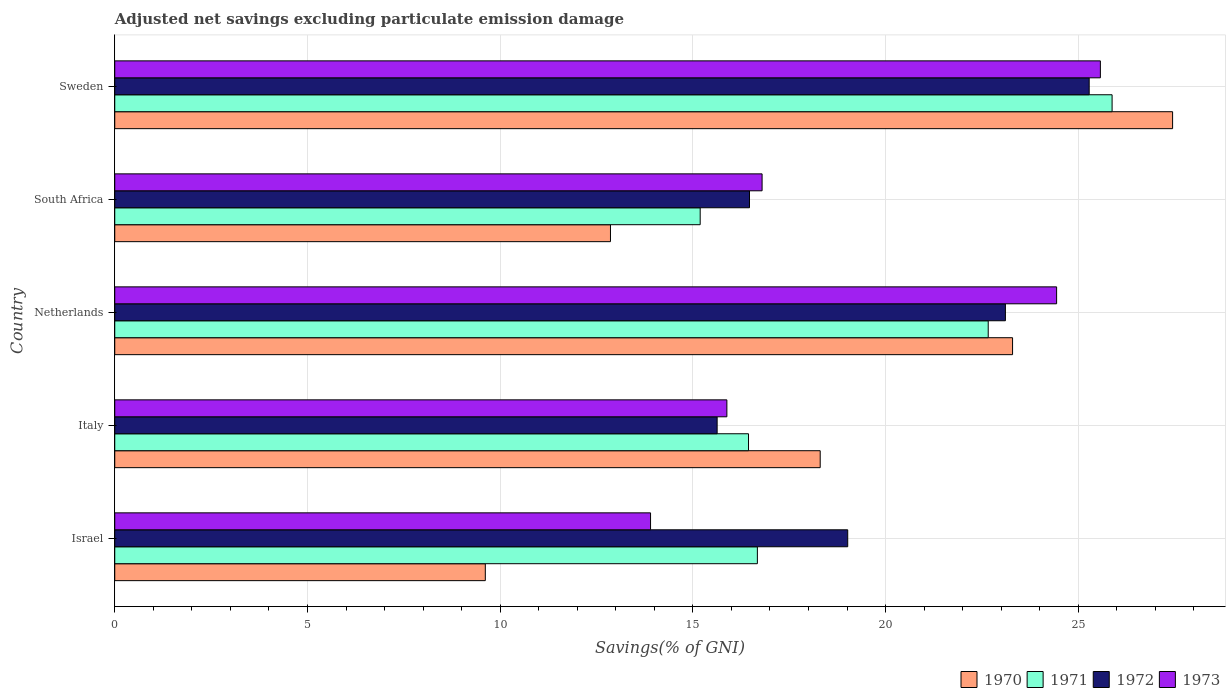What is the adjusted net savings in 1971 in Netherlands?
Your answer should be very brief. 22.66. Across all countries, what is the maximum adjusted net savings in 1971?
Keep it short and to the point. 25.88. Across all countries, what is the minimum adjusted net savings in 1972?
Ensure brevity in your answer.  15.63. In which country was the adjusted net savings in 1971 maximum?
Your response must be concise. Sweden. In which country was the adjusted net savings in 1973 minimum?
Give a very brief answer. Israel. What is the total adjusted net savings in 1973 in the graph?
Your response must be concise. 96.59. What is the difference between the adjusted net savings in 1973 in Israel and that in Italy?
Keep it short and to the point. -1.98. What is the difference between the adjusted net savings in 1972 in Italy and the adjusted net savings in 1971 in Israel?
Offer a very short reply. -1.04. What is the average adjusted net savings in 1970 per country?
Provide a short and direct response. 18.3. What is the difference between the adjusted net savings in 1973 and adjusted net savings in 1970 in South Africa?
Give a very brief answer. 3.93. In how many countries, is the adjusted net savings in 1970 greater than 5 %?
Ensure brevity in your answer.  5. What is the ratio of the adjusted net savings in 1970 in Netherlands to that in Sweden?
Your response must be concise. 0.85. Is the difference between the adjusted net savings in 1973 in Israel and Italy greater than the difference between the adjusted net savings in 1970 in Israel and Italy?
Offer a terse response. Yes. What is the difference between the highest and the second highest adjusted net savings in 1973?
Your answer should be compact. 1.14. What is the difference between the highest and the lowest adjusted net savings in 1970?
Give a very brief answer. 17.83. What does the 2nd bar from the top in Sweden represents?
Your answer should be compact. 1972. What does the 3rd bar from the bottom in Sweden represents?
Provide a short and direct response. 1972. Are all the bars in the graph horizontal?
Provide a short and direct response. Yes. Are the values on the major ticks of X-axis written in scientific E-notation?
Keep it short and to the point. No. Does the graph contain grids?
Make the answer very short. Yes. How are the legend labels stacked?
Give a very brief answer. Horizontal. What is the title of the graph?
Your response must be concise. Adjusted net savings excluding particulate emission damage. What is the label or title of the X-axis?
Your answer should be very brief. Savings(% of GNI). What is the label or title of the Y-axis?
Keep it short and to the point. Country. What is the Savings(% of GNI) of 1970 in Israel?
Offer a terse response. 9.61. What is the Savings(% of GNI) in 1971 in Israel?
Give a very brief answer. 16.67. What is the Savings(% of GNI) of 1972 in Israel?
Give a very brief answer. 19.02. What is the Savings(% of GNI) in 1973 in Israel?
Keep it short and to the point. 13.9. What is the Savings(% of GNI) in 1970 in Italy?
Offer a terse response. 18.3. What is the Savings(% of GNI) in 1971 in Italy?
Your answer should be very brief. 16.44. What is the Savings(% of GNI) in 1972 in Italy?
Keep it short and to the point. 15.63. What is the Savings(% of GNI) of 1973 in Italy?
Your answer should be compact. 15.88. What is the Savings(% of GNI) of 1970 in Netherlands?
Your answer should be compact. 23.3. What is the Savings(% of GNI) of 1971 in Netherlands?
Your answer should be very brief. 22.66. What is the Savings(% of GNI) of 1972 in Netherlands?
Keep it short and to the point. 23.11. What is the Savings(% of GNI) of 1973 in Netherlands?
Keep it short and to the point. 24.44. What is the Savings(% of GNI) in 1970 in South Africa?
Your answer should be compact. 12.86. What is the Savings(% of GNI) of 1971 in South Africa?
Provide a succinct answer. 15.19. What is the Savings(% of GNI) in 1972 in South Africa?
Provide a short and direct response. 16.47. What is the Savings(% of GNI) of 1973 in South Africa?
Make the answer very short. 16.8. What is the Savings(% of GNI) of 1970 in Sweden?
Give a very brief answer. 27.45. What is the Savings(% of GNI) of 1971 in Sweden?
Your answer should be very brief. 25.88. What is the Savings(% of GNI) in 1972 in Sweden?
Offer a very short reply. 25.28. What is the Savings(% of GNI) in 1973 in Sweden?
Keep it short and to the point. 25.57. Across all countries, what is the maximum Savings(% of GNI) of 1970?
Ensure brevity in your answer.  27.45. Across all countries, what is the maximum Savings(% of GNI) of 1971?
Offer a terse response. 25.88. Across all countries, what is the maximum Savings(% of GNI) of 1972?
Offer a very short reply. 25.28. Across all countries, what is the maximum Savings(% of GNI) of 1973?
Your response must be concise. 25.57. Across all countries, what is the minimum Savings(% of GNI) of 1970?
Provide a short and direct response. 9.61. Across all countries, what is the minimum Savings(% of GNI) in 1971?
Provide a short and direct response. 15.19. Across all countries, what is the minimum Savings(% of GNI) of 1972?
Keep it short and to the point. 15.63. Across all countries, what is the minimum Savings(% of GNI) in 1973?
Make the answer very short. 13.9. What is the total Savings(% of GNI) in 1970 in the graph?
Make the answer very short. 91.52. What is the total Savings(% of GNI) of 1971 in the graph?
Your answer should be compact. 96.85. What is the total Savings(% of GNI) in 1972 in the graph?
Offer a very short reply. 99.51. What is the total Savings(% of GNI) of 1973 in the graph?
Make the answer very short. 96.59. What is the difference between the Savings(% of GNI) of 1970 in Israel and that in Italy?
Offer a very short reply. -8.69. What is the difference between the Savings(% of GNI) in 1971 in Israel and that in Italy?
Your answer should be very brief. 0.23. What is the difference between the Savings(% of GNI) in 1972 in Israel and that in Italy?
Your response must be concise. 3.39. What is the difference between the Savings(% of GNI) in 1973 in Israel and that in Italy?
Offer a very short reply. -1.98. What is the difference between the Savings(% of GNI) of 1970 in Israel and that in Netherlands?
Your answer should be compact. -13.68. What is the difference between the Savings(% of GNI) of 1971 in Israel and that in Netherlands?
Make the answer very short. -5.99. What is the difference between the Savings(% of GNI) in 1972 in Israel and that in Netherlands?
Provide a short and direct response. -4.09. What is the difference between the Savings(% of GNI) in 1973 in Israel and that in Netherlands?
Your response must be concise. -10.54. What is the difference between the Savings(% of GNI) of 1970 in Israel and that in South Africa?
Provide a short and direct response. -3.25. What is the difference between the Savings(% of GNI) of 1971 in Israel and that in South Africa?
Ensure brevity in your answer.  1.48. What is the difference between the Savings(% of GNI) of 1972 in Israel and that in South Africa?
Your answer should be very brief. 2.55. What is the difference between the Savings(% of GNI) of 1973 in Israel and that in South Africa?
Ensure brevity in your answer.  -2.89. What is the difference between the Savings(% of GNI) of 1970 in Israel and that in Sweden?
Provide a short and direct response. -17.83. What is the difference between the Savings(% of GNI) of 1971 in Israel and that in Sweden?
Offer a very short reply. -9.2. What is the difference between the Savings(% of GNI) of 1972 in Israel and that in Sweden?
Provide a succinct answer. -6.27. What is the difference between the Savings(% of GNI) of 1973 in Israel and that in Sweden?
Offer a terse response. -11.67. What is the difference between the Savings(% of GNI) of 1970 in Italy and that in Netherlands?
Provide a succinct answer. -4.99. What is the difference between the Savings(% of GNI) of 1971 in Italy and that in Netherlands?
Offer a terse response. -6.22. What is the difference between the Savings(% of GNI) in 1972 in Italy and that in Netherlands?
Offer a terse response. -7.48. What is the difference between the Savings(% of GNI) in 1973 in Italy and that in Netherlands?
Provide a succinct answer. -8.56. What is the difference between the Savings(% of GNI) in 1970 in Italy and that in South Africa?
Give a very brief answer. 5.44. What is the difference between the Savings(% of GNI) of 1971 in Italy and that in South Africa?
Ensure brevity in your answer.  1.25. What is the difference between the Savings(% of GNI) of 1972 in Italy and that in South Africa?
Make the answer very short. -0.84. What is the difference between the Savings(% of GNI) of 1973 in Italy and that in South Africa?
Your answer should be very brief. -0.91. What is the difference between the Savings(% of GNI) of 1970 in Italy and that in Sweden?
Your response must be concise. -9.14. What is the difference between the Savings(% of GNI) in 1971 in Italy and that in Sweden?
Offer a terse response. -9.43. What is the difference between the Savings(% of GNI) of 1972 in Italy and that in Sweden?
Your response must be concise. -9.65. What is the difference between the Savings(% of GNI) in 1973 in Italy and that in Sweden?
Provide a short and direct response. -9.69. What is the difference between the Savings(% of GNI) of 1970 in Netherlands and that in South Africa?
Your answer should be very brief. 10.43. What is the difference between the Savings(% of GNI) of 1971 in Netherlands and that in South Africa?
Offer a very short reply. 7.47. What is the difference between the Savings(% of GNI) in 1972 in Netherlands and that in South Africa?
Your response must be concise. 6.64. What is the difference between the Savings(% of GNI) of 1973 in Netherlands and that in South Africa?
Your response must be concise. 7.64. What is the difference between the Savings(% of GNI) in 1970 in Netherlands and that in Sweden?
Your response must be concise. -4.15. What is the difference between the Savings(% of GNI) of 1971 in Netherlands and that in Sweden?
Make the answer very short. -3.21. What is the difference between the Savings(% of GNI) in 1972 in Netherlands and that in Sweden?
Ensure brevity in your answer.  -2.17. What is the difference between the Savings(% of GNI) of 1973 in Netherlands and that in Sweden?
Offer a terse response. -1.14. What is the difference between the Savings(% of GNI) in 1970 in South Africa and that in Sweden?
Make the answer very short. -14.59. What is the difference between the Savings(% of GNI) in 1971 in South Africa and that in Sweden?
Your response must be concise. -10.69. What is the difference between the Savings(% of GNI) in 1972 in South Africa and that in Sweden?
Your answer should be compact. -8.81. What is the difference between the Savings(% of GNI) in 1973 in South Africa and that in Sweden?
Give a very brief answer. -8.78. What is the difference between the Savings(% of GNI) of 1970 in Israel and the Savings(% of GNI) of 1971 in Italy?
Your answer should be very brief. -6.83. What is the difference between the Savings(% of GNI) of 1970 in Israel and the Savings(% of GNI) of 1972 in Italy?
Provide a short and direct response. -6.02. What is the difference between the Savings(% of GNI) in 1970 in Israel and the Savings(% of GNI) in 1973 in Italy?
Your response must be concise. -6.27. What is the difference between the Savings(% of GNI) in 1971 in Israel and the Savings(% of GNI) in 1972 in Italy?
Your answer should be compact. 1.04. What is the difference between the Savings(% of GNI) in 1971 in Israel and the Savings(% of GNI) in 1973 in Italy?
Make the answer very short. 0.79. What is the difference between the Savings(% of GNI) of 1972 in Israel and the Savings(% of GNI) of 1973 in Italy?
Offer a very short reply. 3.14. What is the difference between the Savings(% of GNI) in 1970 in Israel and the Savings(% of GNI) in 1971 in Netherlands?
Give a very brief answer. -13.05. What is the difference between the Savings(% of GNI) in 1970 in Israel and the Savings(% of GNI) in 1972 in Netherlands?
Provide a short and direct response. -13.49. What is the difference between the Savings(% of GNI) of 1970 in Israel and the Savings(% of GNI) of 1973 in Netherlands?
Ensure brevity in your answer.  -14.82. What is the difference between the Savings(% of GNI) of 1971 in Israel and the Savings(% of GNI) of 1972 in Netherlands?
Give a very brief answer. -6.44. What is the difference between the Savings(% of GNI) of 1971 in Israel and the Savings(% of GNI) of 1973 in Netherlands?
Your response must be concise. -7.76. What is the difference between the Savings(% of GNI) of 1972 in Israel and the Savings(% of GNI) of 1973 in Netherlands?
Make the answer very short. -5.42. What is the difference between the Savings(% of GNI) of 1970 in Israel and the Savings(% of GNI) of 1971 in South Africa?
Keep it short and to the point. -5.58. What is the difference between the Savings(% of GNI) in 1970 in Israel and the Savings(% of GNI) in 1972 in South Africa?
Ensure brevity in your answer.  -6.86. What is the difference between the Savings(% of GNI) of 1970 in Israel and the Savings(% of GNI) of 1973 in South Africa?
Your response must be concise. -7.18. What is the difference between the Savings(% of GNI) of 1971 in Israel and the Savings(% of GNI) of 1972 in South Africa?
Your response must be concise. 0.2. What is the difference between the Savings(% of GNI) in 1971 in Israel and the Savings(% of GNI) in 1973 in South Africa?
Ensure brevity in your answer.  -0.12. What is the difference between the Savings(% of GNI) of 1972 in Israel and the Savings(% of GNI) of 1973 in South Africa?
Provide a short and direct response. 2.22. What is the difference between the Savings(% of GNI) of 1970 in Israel and the Savings(% of GNI) of 1971 in Sweden?
Provide a succinct answer. -16.26. What is the difference between the Savings(% of GNI) in 1970 in Israel and the Savings(% of GNI) in 1972 in Sweden?
Ensure brevity in your answer.  -15.67. What is the difference between the Savings(% of GNI) of 1970 in Israel and the Savings(% of GNI) of 1973 in Sweden?
Provide a succinct answer. -15.96. What is the difference between the Savings(% of GNI) in 1971 in Israel and the Savings(% of GNI) in 1972 in Sweden?
Your response must be concise. -8.61. What is the difference between the Savings(% of GNI) of 1971 in Israel and the Savings(% of GNI) of 1973 in Sweden?
Ensure brevity in your answer.  -8.9. What is the difference between the Savings(% of GNI) of 1972 in Israel and the Savings(% of GNI) of 1973 in Sweden?
Provide a short and direct response. -6.56. What is the difference between the Savings(% of GNI) in 1970 in Italy and the Savings(% of GNI) in 1971 in Netherlands?
Ensure brevity in your answer.  -4.36. What is the difference between the Savings(% of GNI) of 1970 in Italy and the Savings(% of GNI) of 1972 in Netherlands?
Make the answer very short. -4.81. What is the difference between the Savings(% of GNI) of 1970 in Italy and the Savings(% of GNI) of 1973 in Netherlands?
Your response must be concise. -6.13. What is the difference between the Savings(% of GNI) of 1971 in Italy and the Savings(% of GNI) of 1972 in Netherlands?
Keep it short and to the point. -6.67. What is the difference between the Savings(% of GNI) in 1971 in Italy and the Savings(% of GNI) in 1973 in Netherlands?
Ensure brevity in your answer.  -7.99. What is the difference between the Savings(% of GNI) in 1972 in Italy and the Savings(% of GNI) in 1973 in Netherlands?
Ensure brevity in your answer.  -8.81. What is the difference between the Savings(% of GNI) of 1970 in Italy and the Savings(% of GNI) of 1971 in South Africa?
Your answer should be compact. 3.11. What is the difference between the Savings(% of GNI) in 1970 in Italy and the Savings(% of GNI) in 1972 in South Africa?
Your answer should be compact. 1.83. What is the difference between the Savings(% of GNI) in 1970 in Italy and the Savings(% of GNI) in 1973 in South Africa?
Your answer should be very brief. 1.51. What is the difference between the Savings(% of GNI) of 1971 in Italy and the Savings(% of GNI) of 1972 in South Africa?
Offer a very short reply. -0.03. What is the difference between the Savings(% of GNI) in 1971 in Italy and the Savings(% of GNI) in 1973 in South Africa?
Provide a succinct answer. -0.35. What is the difference between the Savings(% of GNI) of 1972 in Italy and the Savings(% of GNI) of 1973 in South Africa?
Offer a terse response. -1.17. What is the difference between the Savings(% of GNI) in 1970 in Italy and the Savings(% of GNI) in 1971 in Sweden?
Your answer should be compact. -7.57. What is the difference between the Savings(% of GNI) in 1970 in Italy and the Savings(% of GNI) in 1972 in Sweden?
Your answer should be compact. -6.98. What is the difference between the Savings(% of GNI) in 1970 in Italy and the Savings(% of GNI) in 1973 in Sweden?
Give a very brief answer. -7.27. What is the difference between the Savings(% of GNI) of 1971 in Italy and the Savings(% of GNI) of 1972 in Sweden?
Keep it short and to the point. -8.84. What is the difference between the Savings(% of GNI) in 1971 in Italy and the Savings(% of GNI) in 1973 in Sweden?
Ensure brevity in your answer.  -9.13. What is the difference between the Savings(% of GNI) of 1972 in Italy and the Savings(% of GNI) of 1973 in Sweden?
Your response must be concise. -9.94. What is the difference between the Savings(% of GNI) in 1970 in Netherlands and the Savings(% of GNI) in 1971 in South Africa?
Your answer should be very brief. 8.11. What is the difference between the Savings(% of GNI) in 1970 in Netherlands and the Savings(% of GNI) in 1972 in South Africa?
Your response must be concise. 6.83. What is the difference between the Savings(% of GNI) of 1970 in Netherlands and the Savings(% of GNI) of 1973 in South Africa?
Offer a very short reply. 6.5. What is the difference between the Savings(% of GNI) in 1971 in Netherlands and the Savings(% of GNI) in 1972 in South Africa?
Offer a very short reply. 6.19. What is the difference between the Savings(% of GNI) of 1971 in Netherlands and the Savings(% of GNI) of 1973 in South Africa?
Keep it short and to the point. 5.87. What is the difference between the Savings(% of GNI) in 1972 in Netherlands and the Savings(% of GNI) in 1973 in South Africa?
Ensure brevity in your answer.  6.31. What is the difference between the Savings(% of GNI) in 1970 in Netherlands and the Savings(% of GNI) in 1971 in Sweden?
Your response must be concise. -2.58. What is the difference between the Savings(% of GNI) in 1970 in Netherlands and the Savings(% of GNI) in 1972 in Sweden?
Your answer should be very brief. -1.99. What is the difference between the Savings(% of GNI) in 1970 in Netherlands and the Savings(% of GNI) in 1973 in Sweden?
Offer a terse response. -2.28. What is the difference between the Savings(% of GNI) in 1971 in Netherlands and the Savings(% of GNI) in 1972 in Sweden?
Your answer should be compact. -2.62. What is the difference between the Savings(% of GNI) of 1971 in Netherlands and the Savings(% of GNI) of 1973 in Sweden?
Ensure brevity in your answer.  -2.91. What is the difference between the Savings(% of GNI) in 1972 in Netherlands and the Savings(% of GNI) in 1973 in Sweden?
Offer a terse response. -2.46. What is the difference between the Savings(% of GNI) of 1970 in South Africa and the Savings(% of GNI) of 1971 in Sweden?
Offer a very short reply. -13.02. What is the difference between the Savings(% of GNI) of 1970 in South Africa and the Savings(% of GNI) of 1972 in Sweden?
Offer a terse response. -12.42. What is the difference between the Savings(% of GNI) in 1970 in South Africa and the Savings(% of GNI) in 1973 in Sweden?
Make the answer very short. -12.71. What is the difference between the Savings(% of GNI) of 1971 in South Africa and the Savings(% of GNI) of 1972 in Sweden?
Provide a short and direct response. -10.09. What is the difference between the Savings(% of GNI) in 1971 in South Africa and the Savings(% of GNI) in 1973 in Sweden?
Provide a short and direct response. -10.38. What is the difference between the Savings(% of GNI) in 1972 in South Africa and the Savings(% of GNI) in 1973 in Sweden?
Your response must be concise. -9.1. What is the average Savings(% of GNI) in 1970 per country?
Your response must be concise. 18.3. What is the average Savings(% of GNI) of 1971 per country?
Keep it short and to the point. 19.37. What is the average Savings(% of GNI) in 1972 per country?
Provide a short and direct response. 19.9. What is the average Savings(% of GNI) of 1973 per country?
Your answer should be very brief. 19.32. What is the difference between the Savings(% of GNI) in 1970 and Savings(% of GNI) in 1971 in Israel?
Provide a succinct answer. -7.06. What is the difference between the Savings(% of GNI) of 1970 and Savings(% of GNI) of 1972 in Israel?
Your answer should be compact. -9.4. What is the difference between the Savings(% of GNI) of 1970 and Savings(% of GNI) of 1973 in Israel?
Your response must be concise. -4.29. What is the difference between the Savings(% of GNI) in 1971 and Savings(% of GNI) in 1972 in Israel?
Your response must be concise. -2.34. What is the difference between the Savings(% of GNI) of 1971 and Savings(% of GNI) of 1973 in Israel?
Offer a terse response. 2.77. What is the difference between the Savings(% of GNI) in 1972 and Savings(% of GNI) in 1973 in Israel?
Your answer should be very brief. 5.12. What is the difference between the Savings(% of GNI) in 1970 and Savings(% of GNI) in 1971 in Italy?
Offer a terse response. 1.86. What is the difference between the Savings(% of GNI) in 1970 and Savings(% of GNI) in 1972 in Italy?
Offer a very short reply. 2.67. What is the difference between the Savings(% of GNI) of 1970 and Savings(% of GNI) of 1973 in Italy?
Make the answer very short. 2.42. What is the difference between the Savings(% of GNI) in 1971 and Savings(% of GNI) in 1972 in Italy?
Provide a succinct answer. 0.81. What is the difference between the Savings(% of GNI) in 1971 and Savings(% of GNI) in 1973 in Italy?
Offer a very short reply. 0.56. What is the difference between the Savings(% of GNI) in 1972 and Savings(% of GNI) in 1973 in Italy?
Ensure brevity in your answer.  -0.25. What is the difference between the Savings(% of GNI) in 1970 and Savings(% of GNI) in 1971 in Netherlands?
Your answer should be very brief. 0.63. What is the difference between the Savings(% of GNI) of 1970 and Savings(% of GNI) of 1972 in Netherlands?
Your response must be concise. 0.19. What is the difference between the Savings(% of GNI) of 1970 and Savings(% of GNI) of 1973 in Netherlands?
Provide a succinct answer. -1.14. What is the difference between the Savings(% of GNI) in 1971 and Savings(% of GNI) in 1972 in Netherlands?
Give a very brief answer. -0.45. What is the difference between the Savings(% of GNI) in 1971 and Savings(% of GNI) in 1973 in Netherlands?
Offer a terse response. -1.77. What is the difference between the Savings(% of GNI) of 1972 and Savings(% of GNI) of 1973 in Netherlands?
Ensure brevity in your answer.  -1.33. What is the difference between the Savings(% of GNI) of 1970 and Savings(% of GNI) of 1971 in South Africa?
Your response must be concise. -2.33. What is the difference between the Savings(% of GNI) in 1970 and Savings(% of GNI) in 1972 in South Africa?
Keep it short and to the point. -3.61. What is the difference between the Savings(% of GNI) in 1970 and Savings(% of GNI) in 1973 in South Africa?
Your answer should be compact. -3.93. What is the difference between the Savings(% of GNI) of 1971 and Savings(% of GNI) of 1972 in South Africa?
Ensure brevity in your answer.  -1.28. What is the difference between the Savings(% of GNI) in 1971 and Savings(% of GNI) in 1973 in South Africa?
Offer a terse response. -1.61. What is the difference between the Savings(% of GNI) in 1972 and Savings(% of GNI) in 1973 in South Africa?
Ensure brevity in your answer.  -0.33. What is the difference between the Savings(% of GNI) of 1970 and Savings(% of GNI) of 1971 in Sweden?
Offer a very short reply. 1.57. What is the difference between the Savings(% of GNI) in 1970 and Savings(% of GNI) in 1972 in Sweden?
Your response must be concise. 2.16. What is the difference between the Savings(% of GNI) of 1970 and Savings(% of GNI) of 1973 in Sweden?
Your response must be concise. 1.87. What is the difference between the Savings(% of GNI) in 1971 and Savings(% of GNI) in 1972 in Sweden?
Your answer should be compact. 0.59. What is the difference between the Savings(% of GNI) of 1971 and Savings(% of GNI) of 1973 in Sweden?
Provide a succinct answer. 0.3. What is the difference between the Savings(% of GNI) in 1972 and Savings(% of GNI) in 1973 in Sweden?
Make the answer very short. -0.29. What is the ratio of the Savings(% of GNI) of 1970 in Israel to that in Italy?
Keep it short and to the point. 0.53. What is the ratio of the Savings(% of GNI) in 1972 in Israel to that in Italy?
Your response must be concise. 1.22. What is the ratio of the Savings(% of GNI) of 1973 in Israel to that in Italy?
Provide a succinct answer. 0.88. What is the ratio of the Savings(% of GNI) in 1970 in Israel to that in Netherlands?
Ensure brevity in your answer.  0.41. What is the ratio of the Savings(% of GNI) of 1971 in Israel to that in Netherlands?
Offer a very short reply. 0.74. What is the ratio of the Savings(% of GNI) in 1972 in Israel to that in Netherlands?
Provide a succinct answer. 0.82. What is the ratio of the Savings(% of GNI) in 1973 in Israel to that in Netherlands?
Your answer should be very brief. 0.57. What is the ratio of the Savings(% of GNI) of 1970 in Israel to that in South Africa?
Make the answer very short. 0.75. What is the ratio of the Savings(% of GNI) of 1971 in Israel to that in South Africa?
Make the answer very short. 1.1. What is the ratio of the Savings(% of GNI) in 1972 in Israel to that in South Africa?
Provide a short and direct response. 1.15. What is the ratio of the Savings(% of GNI) in 1973 in Israel to that in South Africa?
Make the answer very short. 0.83. What is the ratio of the Savings(% of GNI) of 1970 in Israel to that in Sweden?
Your answer should be compact. 0.35. What is the ratio of the Savings(% of GNI) of 1971 in Israel to that in Sweden?
Your answer should be very brief. 0.64. What is the ratio of the Savings(% of GNI) of 1972 in Israel to that in Sweden?
Offer a terse response. 0.75. What is the ratio of the Savings(% of GNI) of 1973 in Israel to that in Sweden?
Your answer should be compact. 0.54. What is the ratio of the Savings(% of GNI) of 1970 in Italy to that in Netherlands?
Provide a short and direct response. 0.79. What is the ratio of the Savings(% of GNI) of 1971 in Italy to that in Netherlands?
Your answer should be very brief. 0.73. What is the ratio of the Savings(% of GNI) in 1972 in Italy to that in Netherlands?
Your response must be concise. 0.68. What is the ratio of the Savings(% of GNI) of 1973 in Italy to that in Netherlands?
Provide a short and direct response. 0.65. What is the ratio of the Savings(% of GNI) of 1970 in Italy to that in South Africa?
Provide a short and direct response. 1.42. What is the ratio of the Savings(% of GNI) of 1971 in Italy to that in South Africa?
Offer a terse response. 1.08. What is the ratio of the Savings(% of GNI) in 1972 in Italy to that in South Africa?
Make the answer very short. 0.95. What is the ratio of the Savings(% of GNI) in 1973 in Italy to that in South Africa?
Make the answer very short. 0.95. What is the ratio of the Savings(% of GNI) in 1970 in Italy to that in Sweden?
Make the answer very short. 0.67. What is the ratio of the Savings(% of GNI) of 1971 in Italy to that in Sweden?
Your answer should be very brief. 0.64. What is the ratio of the Savings(% of GNI) in 1972 in Italy to that in Sweden?
Your answer should be very brief. 0.62. What is the ratio of the Savings(% of GNI) of 1973 in Italy to that in Sweden?
Offer a very short reply. 0.62. What is the ratio of the Savings(% of GNI) of 1970 in Netherlands to that in South Africa?
Provide a short and direct response. 1.81. What is the ratio of the Savings(% of GNI) in 1971 in Netherlands to that in South Africa?
Offer a very short reply. 1.49. What is the ratio of the Savings(% of GNI) in 1972 in Netherlands to that in South Africa?
Offer a very short reply. 1.4. What is the ratio of the Savings(% of GNI) of 1973 in Netherlands to that in South Africa?
Offer a terse response. 1.46. What is the ratio of the Savings(% of GNI) of 1970 in Netherlands to that in Sweden?
Make the answer very short. 0.85. What is the ratio of the Savings(% of GNI) of 1971 in Netherlands to that in Sweden?
Your answer should be very brief. 0.88. What is the ratio of the Savings(% of GNI) in 1972 in Netherlands to that in Sweden?
Provide a succinct answer. 0.91. What is the ratio of the Savings(% of GNI) of 1973 in Netherlands to that in Sweden?
Your response must be concise. 0.96. What is the ratio of the Savings(% of GNI) in 1970 in South Africa to that in Sweden?
Make the answer very short. 0.47. What is the ratio of the Savings(% of GNI) of 1971 in South Africa to that in Sweden?
Keep it short and to the point. 0.59. What is the ratio of the Savings(% of GNI) of 1972 in South Africa to that in Sweden?
Make the answer very short. 0.65. What is the ratio of the Savings(% of GNI) of 1973 in South Africa to that in Sweden?
Your answer should be compact. 0.66. What is the difference between the highest and the second highest Savings(% of GNI) in 1970?
Offer a very short reply. 4.15. What is the difference between the highest and the second highest Savings(% of GNI) of 1971?
Ensure brevity in your answer.  3.21. What is the difference between the highest and the second highest Savings(% of GNI) of 1972?
Ensure brevity in your answer.  2.17. What is the difference between the highest and the second highest Savings(% of GNI) in 1973?
Your response must be concise. 1.14. What is the difference between the highest and the lowest Savings(% of GNI) in 1970?
Your answer should be compact. 17.83. What is the difference between the highest and the lowest Savings(% of GNI) in 1971?
Your answer should be compact. 10.69. What is the difference between the highest and the lowest Savings(% of GNI) of 1972?
Ensure brevity in your answer.  9.65. What is the difference between the highest and the lowest Savings(% of GNI) in 1973?
Provide a short and direct response. 11.67. 